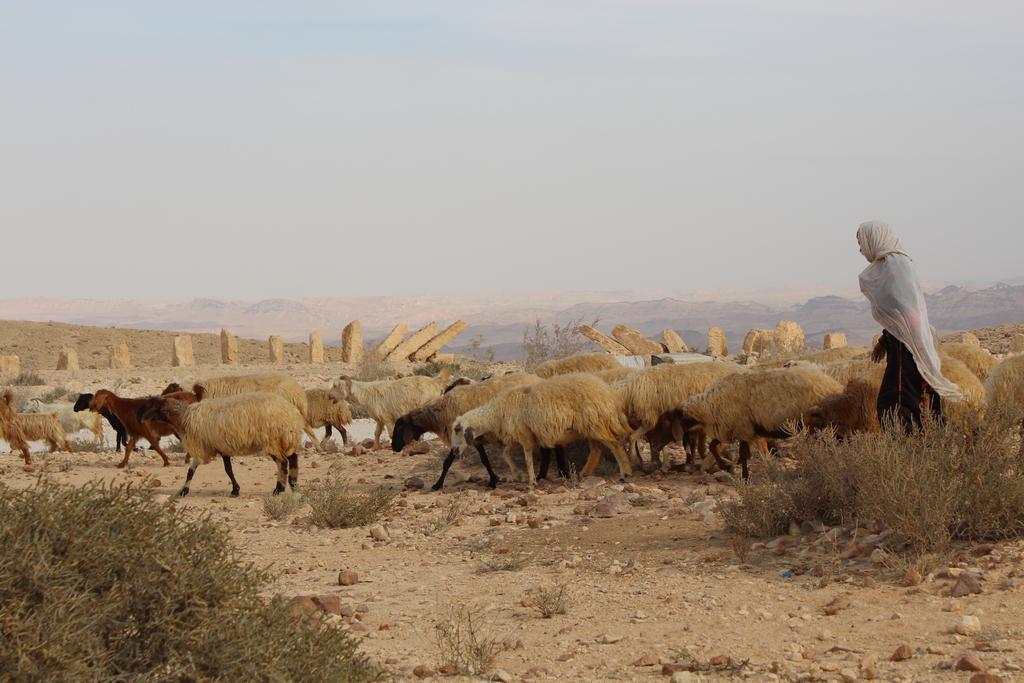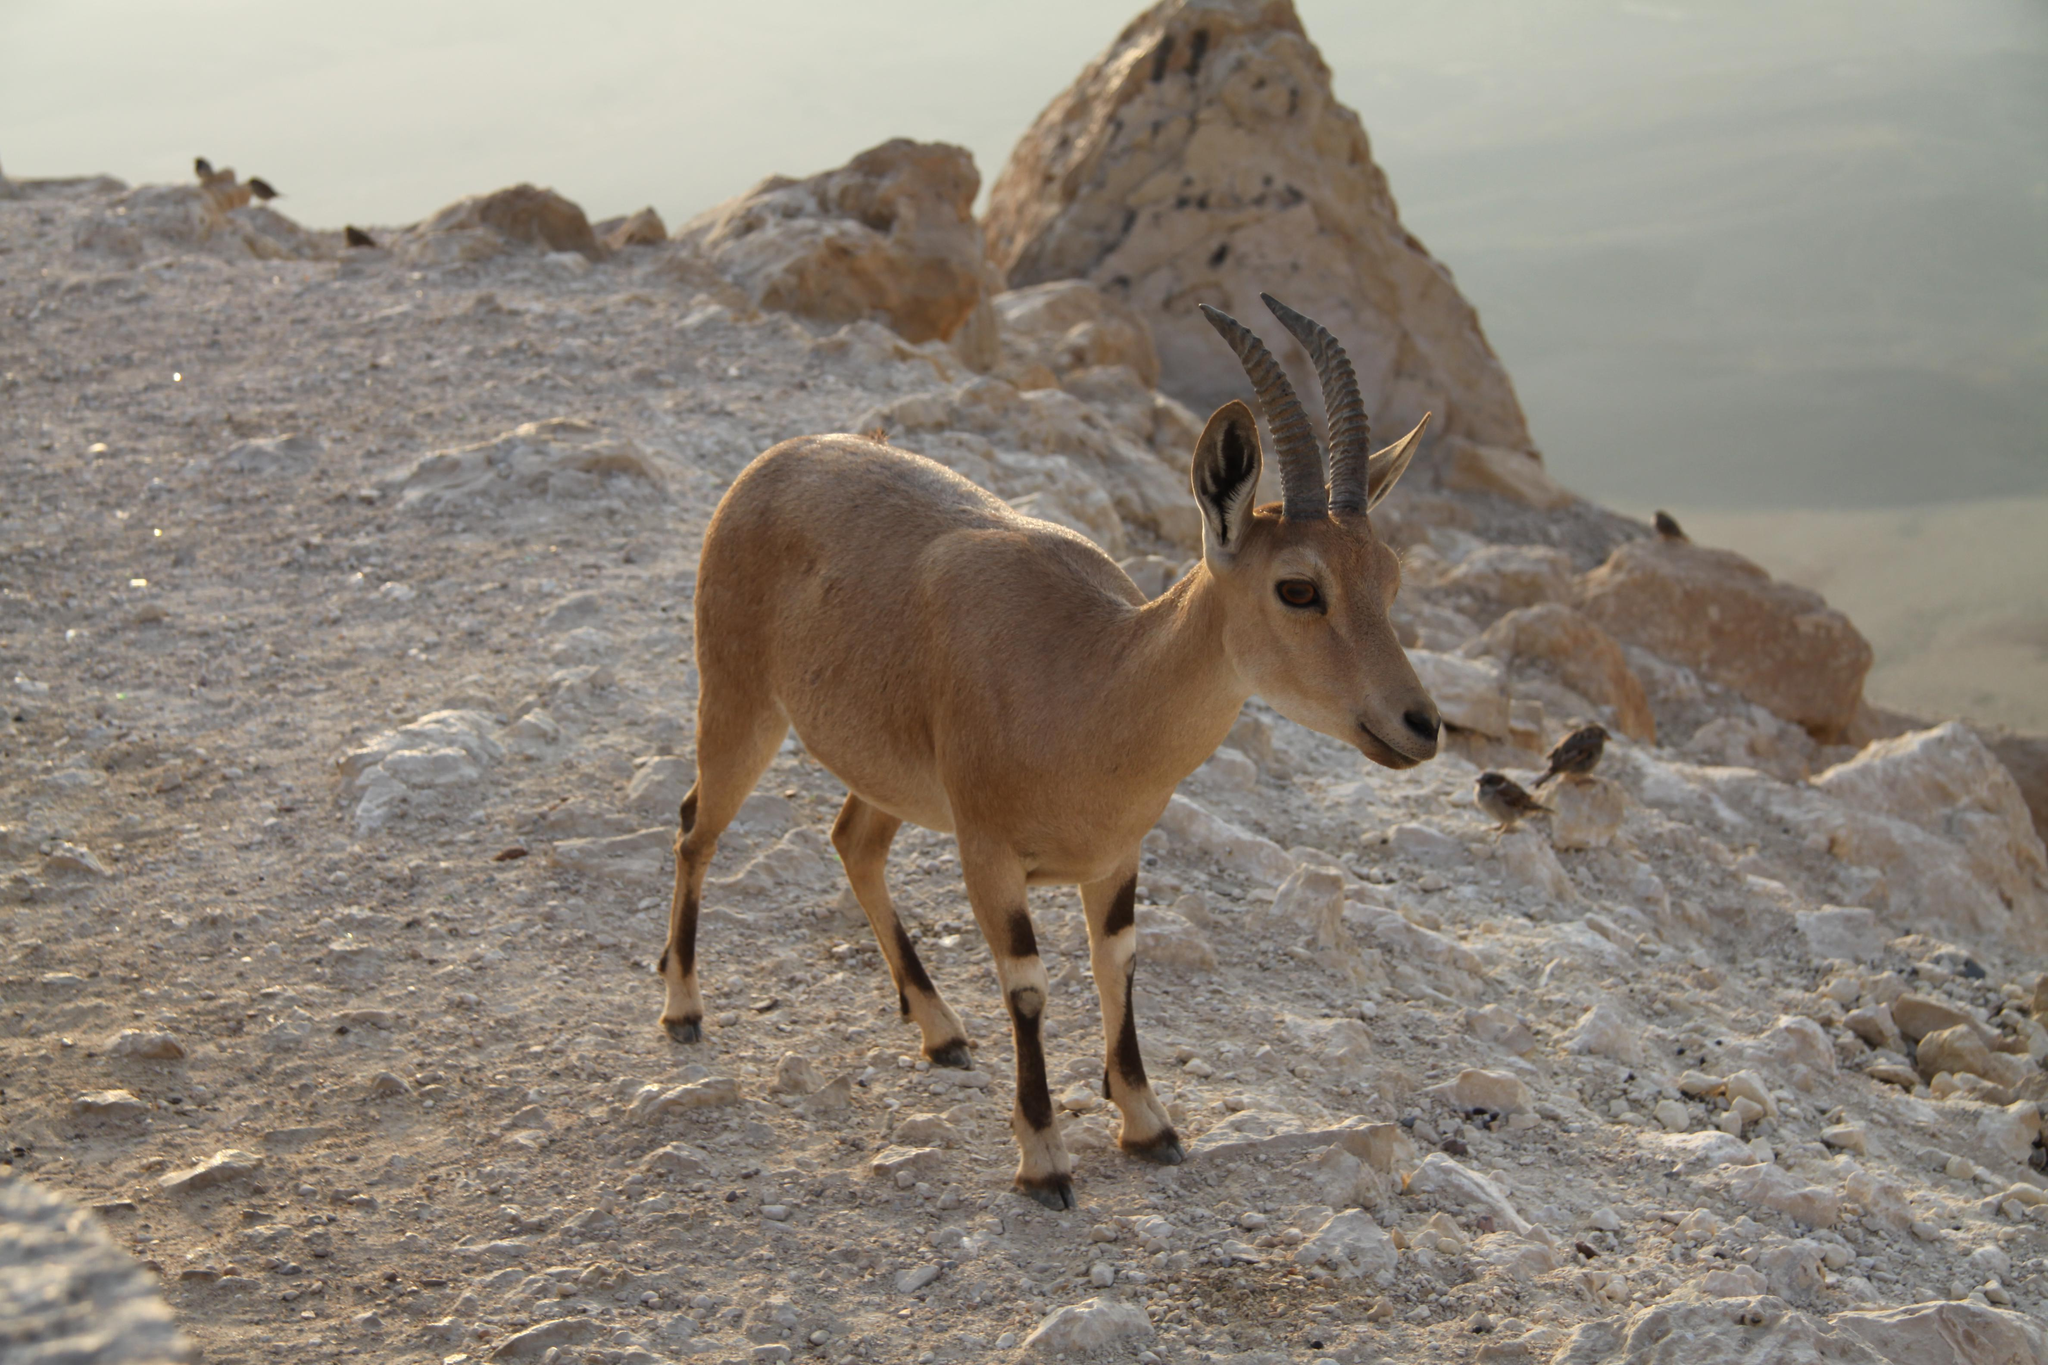The first image is the image on the left, the second image is the image on the right. Examine the images to the left and right. Is the description "An image includes a hooved animal standing on the edge of a low man-made wall." accurate? Answer yes or no. No. The first image is the image on the left, the second image is the image on the right. Evaluate the accuracy of this statement regarding the images: "A single animal is standing on a rocky area in the image on the left.". Is it true? Answer yes or no. No. 